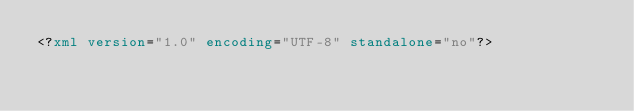Convert code to text. <code><loc_0><loc_0><loc_500><loc_500><_XML_><?xml version="1.0" encoding="UTF-8" standalone="no"?></code> 